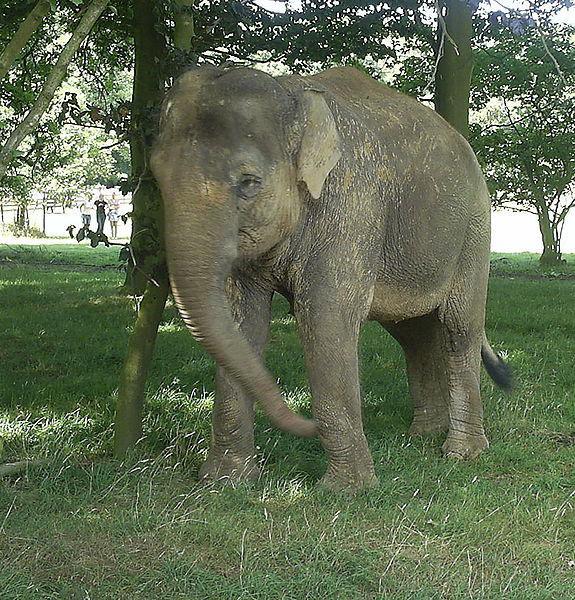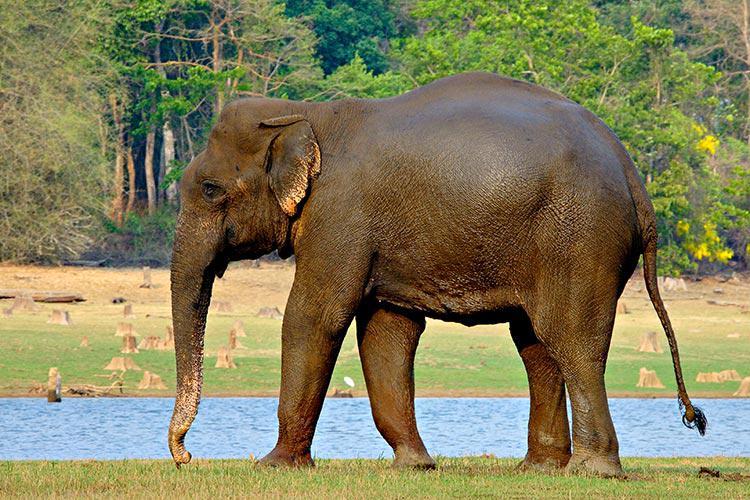The first image is the image on the left, the second image is the image on the right. For the images shown, is this caption "Only one image includes an elephant with prominent tusks." true? Answer yes or no. No. The first image is the image on the left, the second image is the image on the right. For the images displayed, is the sentence "One of the elephants is near an area of water." factually correct? Answer yes or no. Yes. 